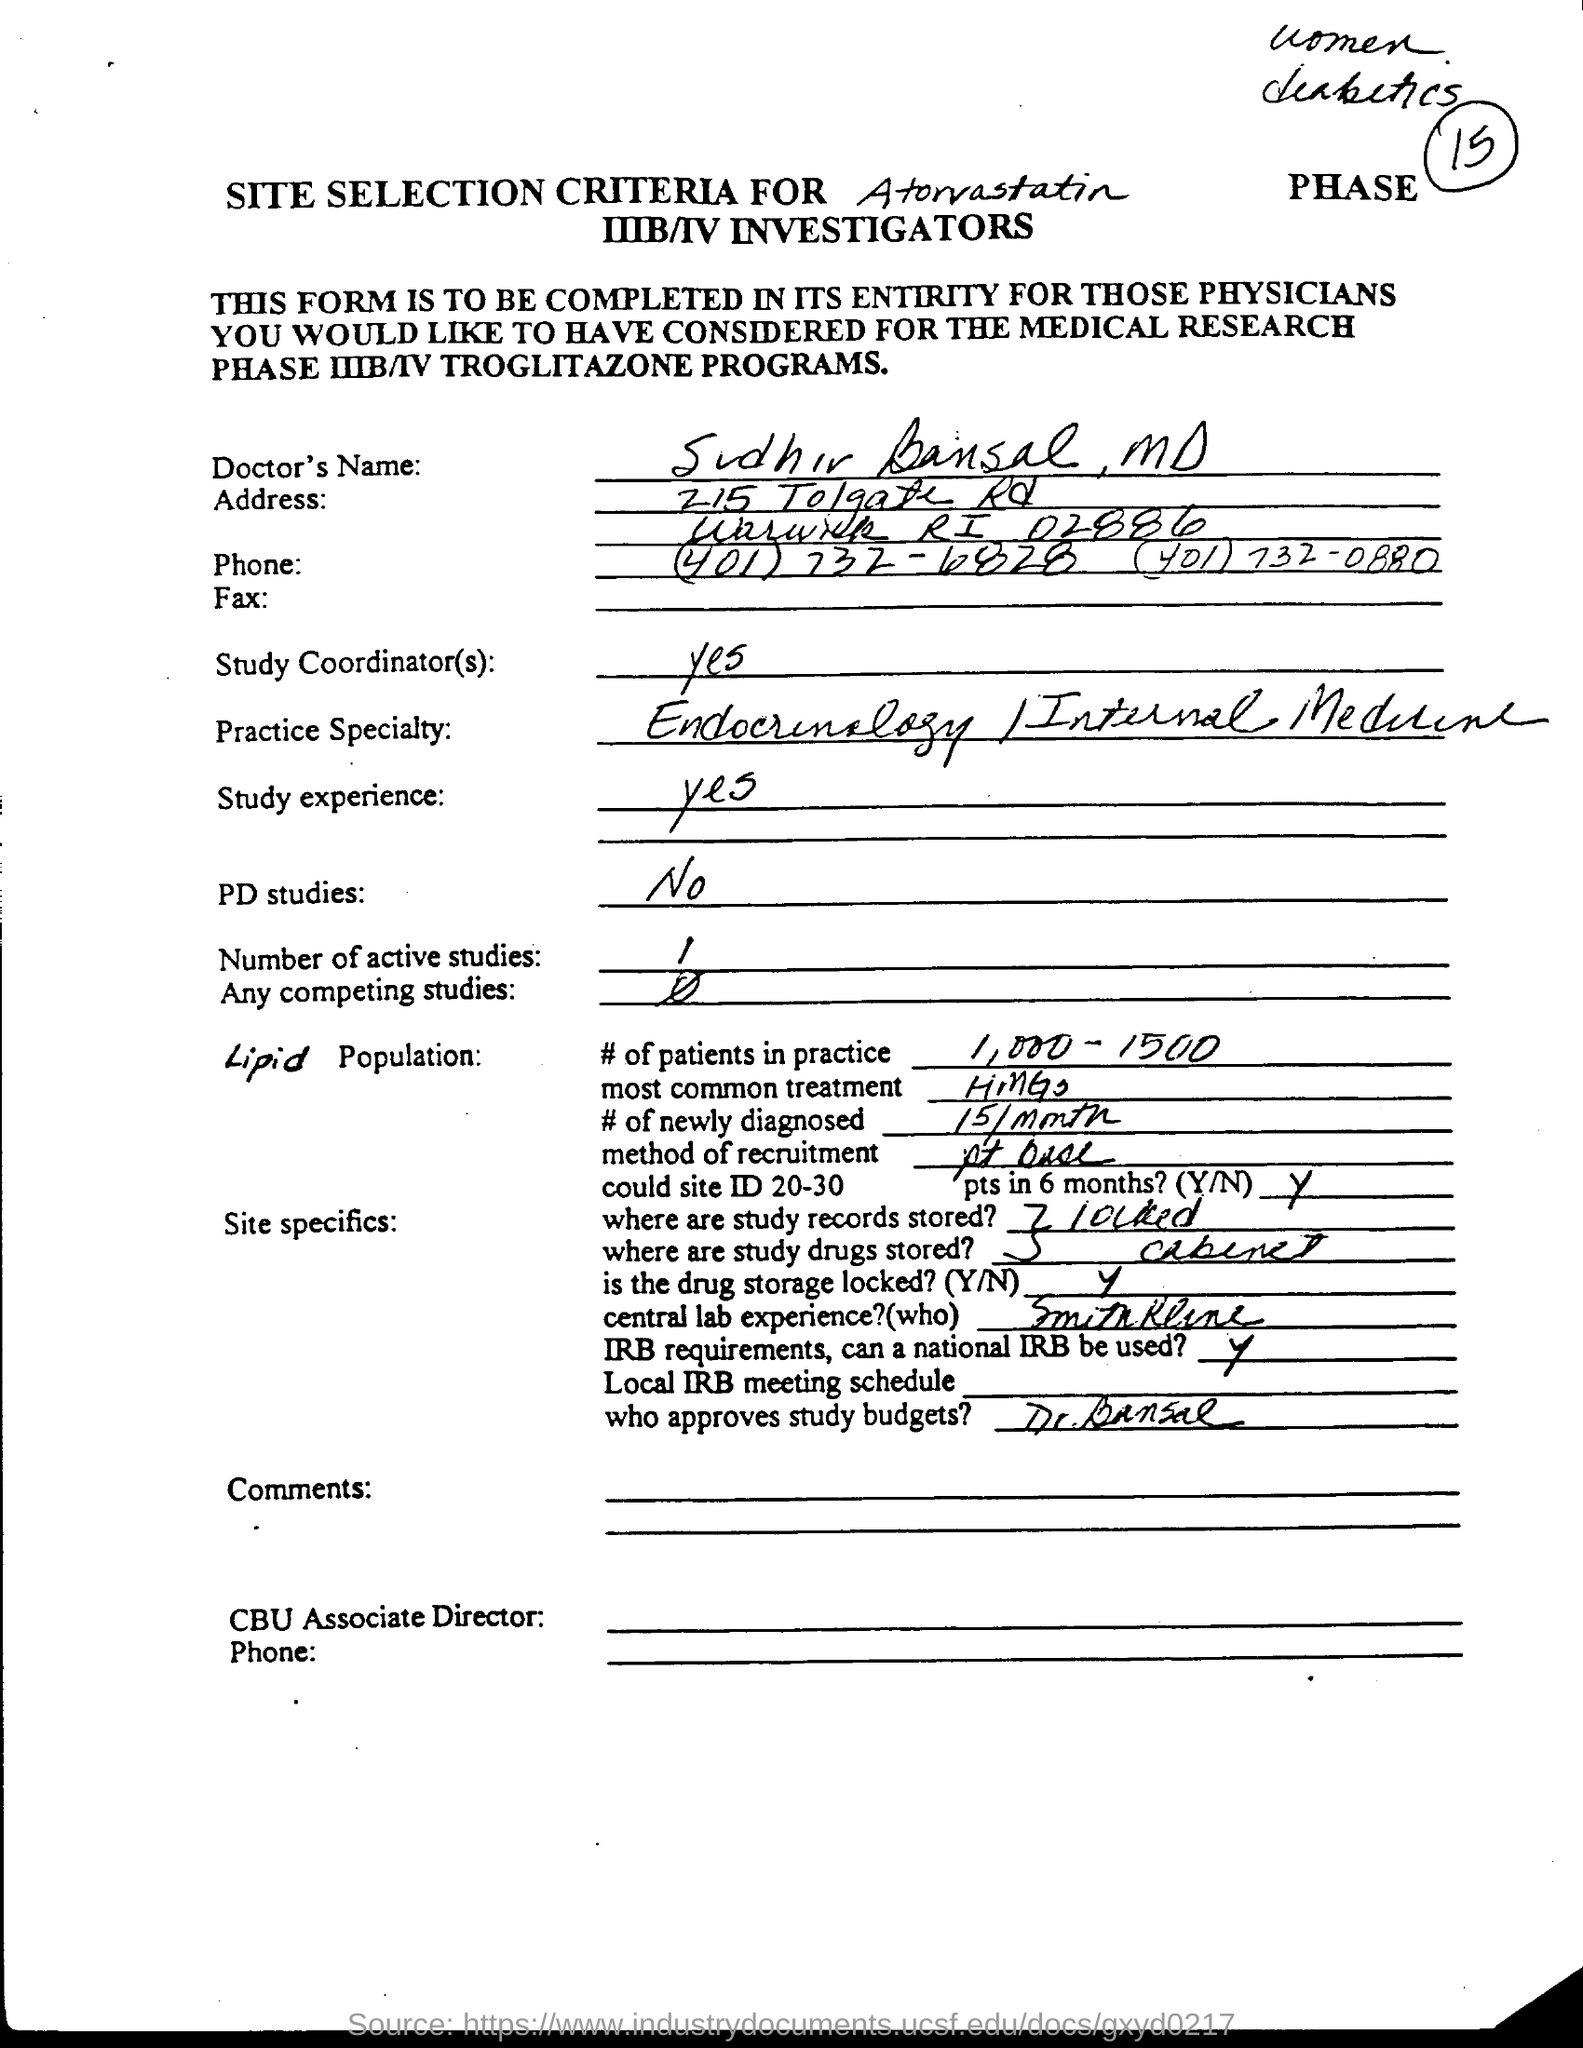Mention a couple of crucial points in this snapshot. The name of the Doctor is Sudhir Bansal, MD. 